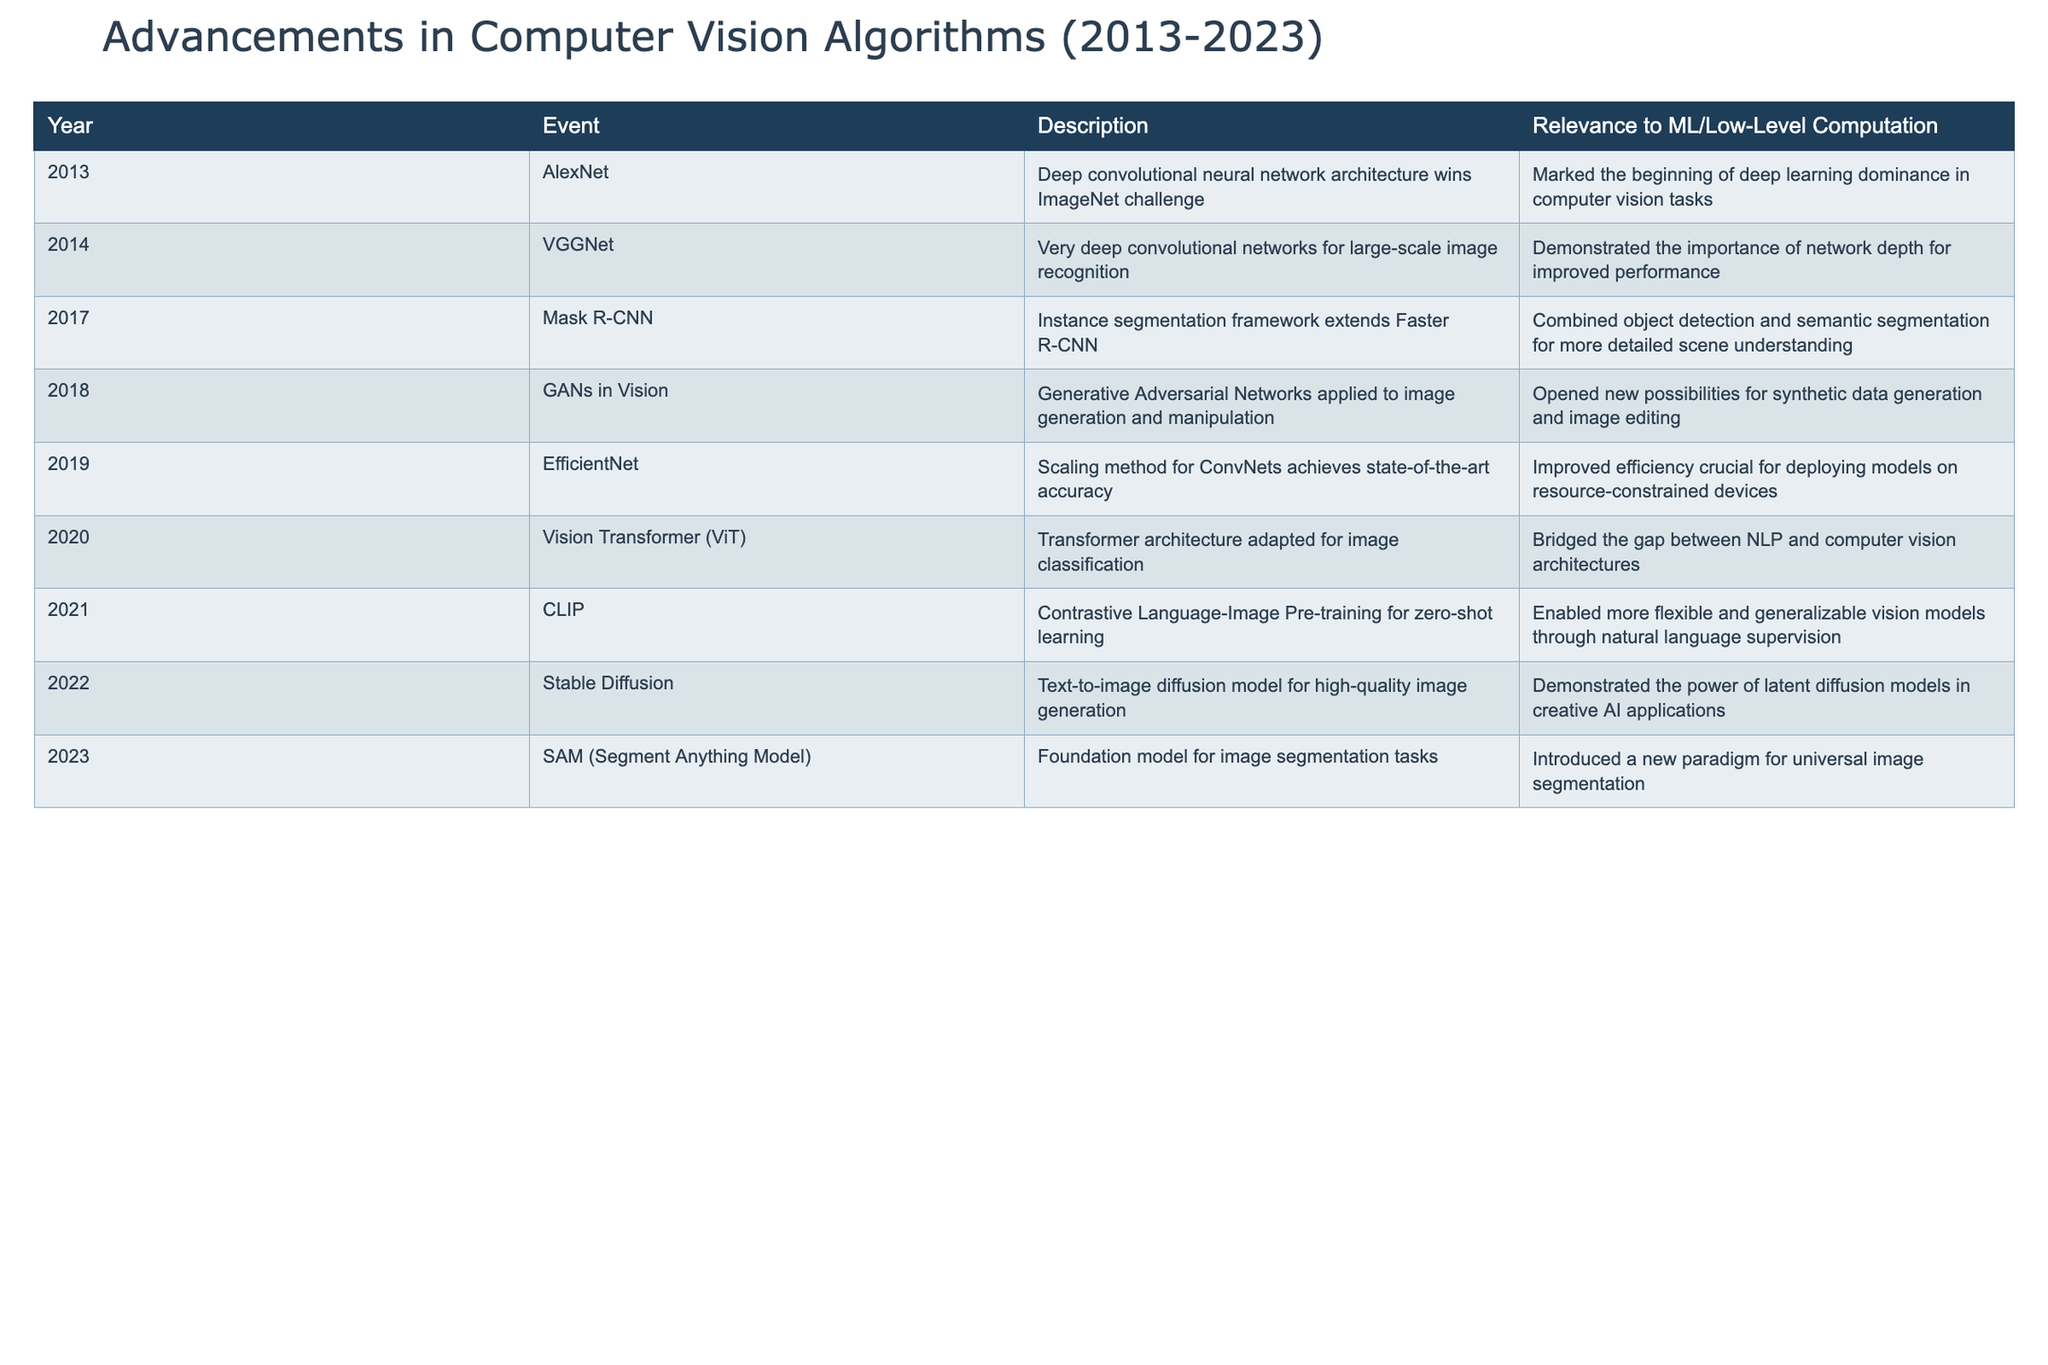What year was AlexNet introduced? AlexNet is listed in the table under the year 2013.
Answer: 2013 Which algorithm was released in 2018 and focused on image generation? The table shows that in 2018, GANs were applied to image generation and manipulation.
Answer: GANs in Vision How many advancements were made in the field of computer vision in the year 2021? The table lists only one event in 2021, which is the introduction of CLIP.
Answer: 1 What is the main significance of the EfficientNet architecture introduced in 2019? According to the table, EfficientNet improved efficiency for deploying models on resource-constrained devices.
Answer: Improved efficiency Which two models introduced after 2020 focus on generative capabilities in images? The table indicates that GANs in Vision (2018) and Stable Diffusion (2022) both focus on generative capabilities in images.
Answer: GANs in Vision and Stable Diffusion What advancement in 2017 combined object detection and semantic segmentation? The table specifically notes that Mask R-CNN combined object detection and semantic segmentation for better scene understanding.
Answer: Mask R-CNN Did any event in 2023 introduce a foundation model for image segmentation tasks? Yes, the SAM (Segment Anything Model) introduced in 2023 is described as a foundation model for image segmentation tasks.
Answer: Yes What was the year with the earliest introduction of models that integrated language and vision? According to the table, CLIP in 2021 is the earliest model that integrated language and vision through contrastive learning.
Answer: 2021 What percentage of the advancements focused on generative models out of the total events listed? There are 3 advancements related to generative models (GANs, Stable Diffusion, and a semantic model) out of 11 total events. Thus, the percentage is (3/11)*100, which is approximately 27.27%.
Answer: 27.27% 